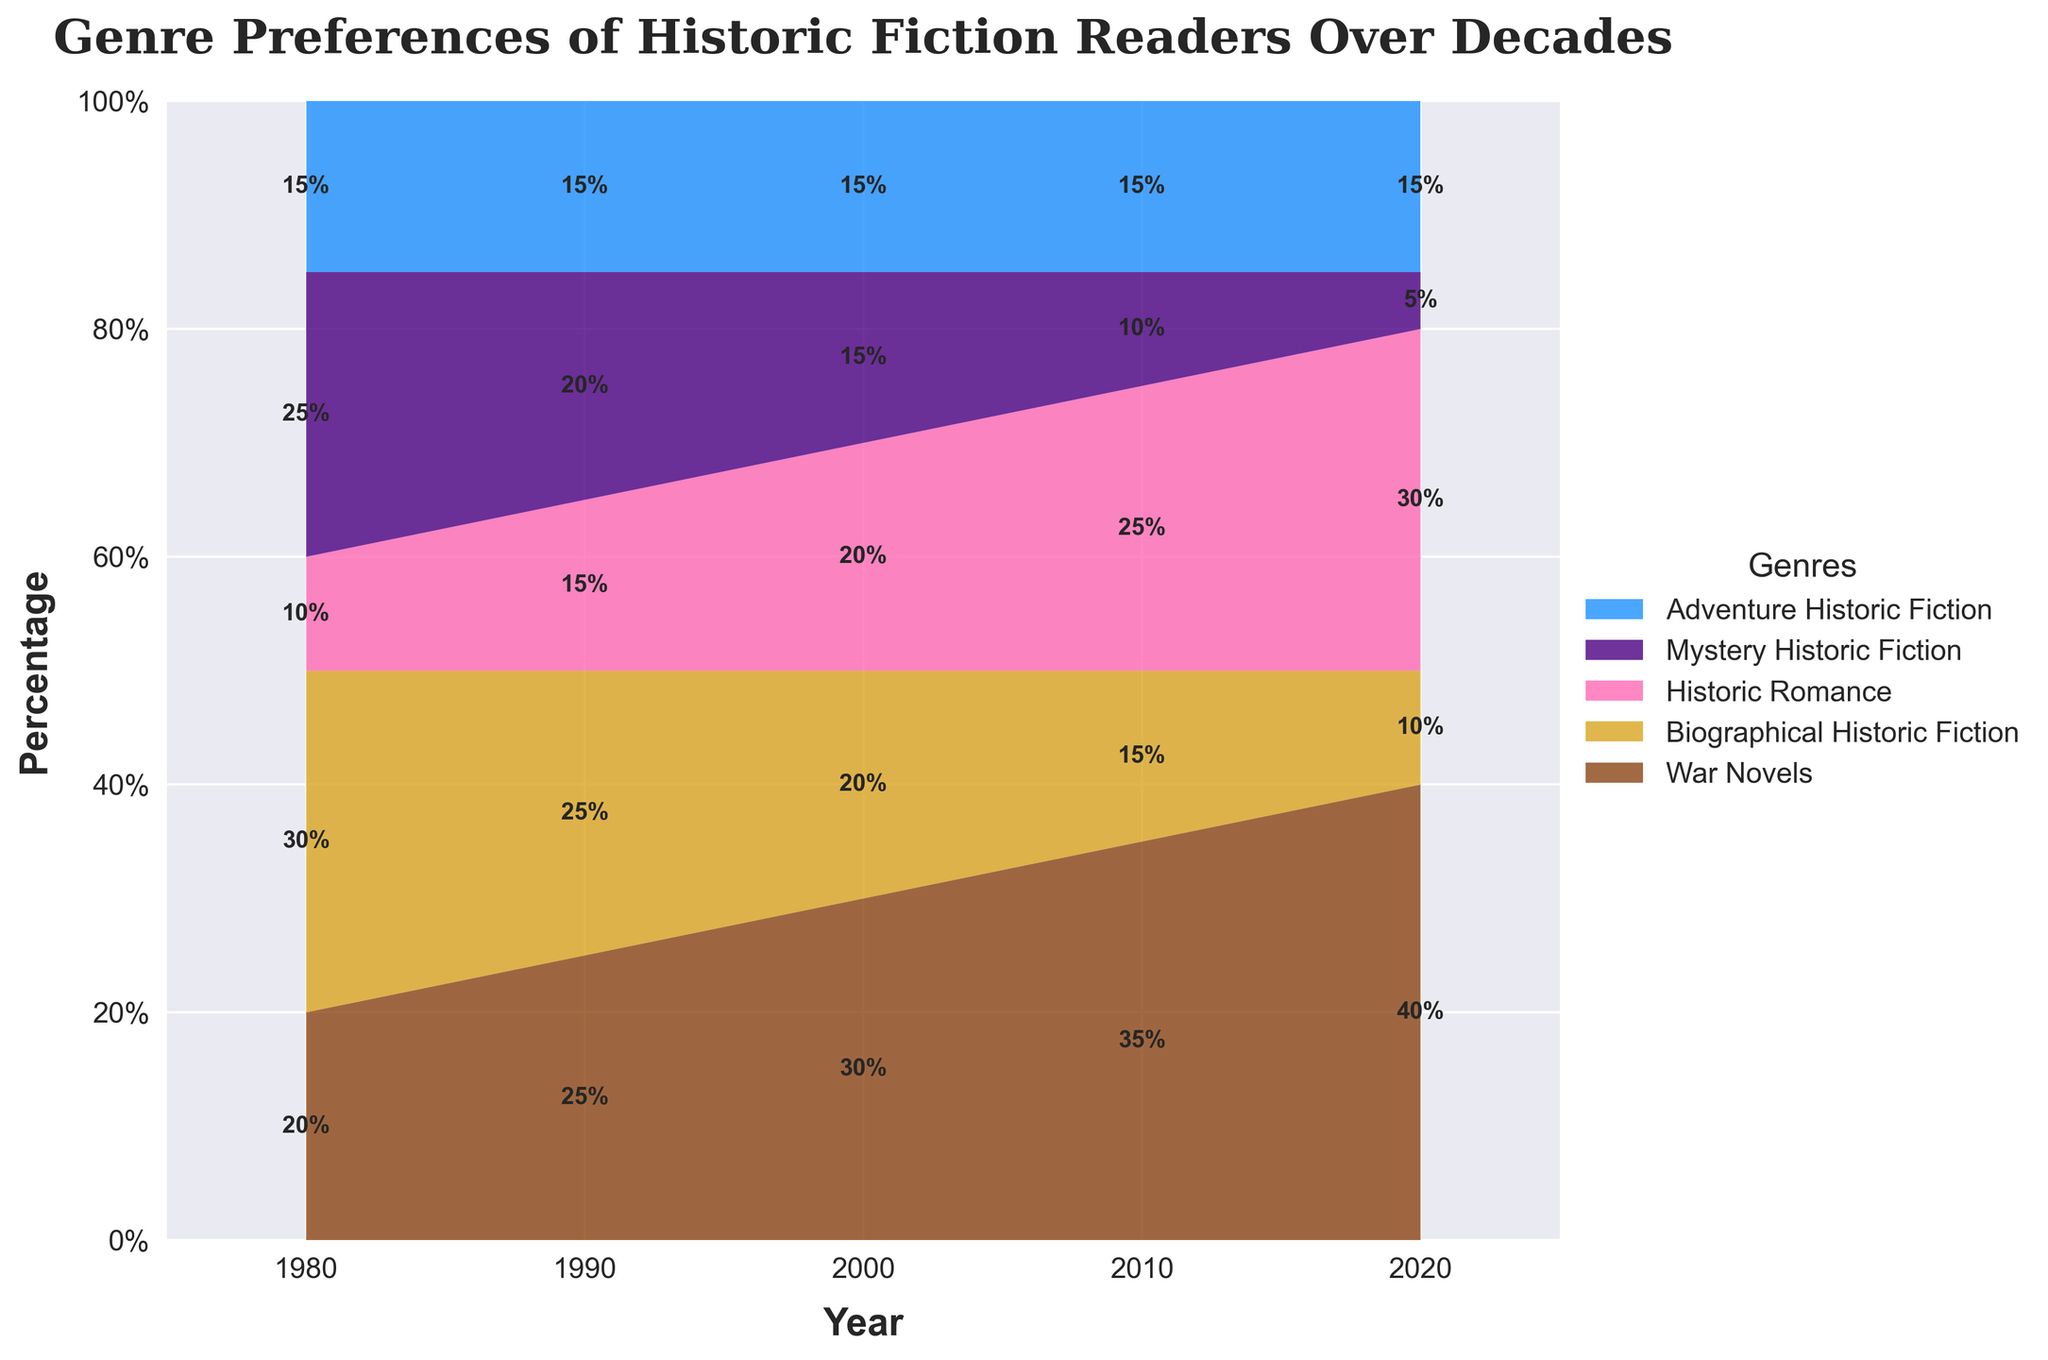What is the title of the figure? The title is usually located at the top of the figure and serves to provide an overview of the chart's content. In this case, the title reads "Genre Preferences of Historic Fiction Readers Over Decades".
Answer: Genre Preferences of Historic Fiction Readers Over Decades How many genres are shown in the figure? The figure includes several distinctly colored areas, each representing a different genre. By counting these areas, we find there are five genres represented: War Novels, Biographical Historic Fiction, Historic Romance, Mystery Historic Fiction, and Adventure Historic Fiction.
Answer: Five Which genre had the highest preference in 1980? To identify the genre with the highest preference in 1980, we look for the genre with the largest area at that year on the x-axis. War Novels and Adventure Historic Fiction have higher proportions compared to others, but the War Novels has the highest preference.
Answer: War Novels How did the preference for Historic Romance change from 1980 to 2020? We observe the vertical breadth of the area corresponding to Historic Romance at 1980 and 2020. In 1980, Historic Romance had around 10%, whereas in 2020, it increased to around 30%.
Answer: Increased Which genre's preference decreased the most from 1980 to 2020? To find the genre with the most significant decrease, compare the vertical heights of each area from 1980 to 2020. Biographical Historic Fiction decreased from 30% in 1980 to 10% in 2020.
Answer: Biographical Historic Fiction What is the combined percentage of Mystery Historic Fiction and Adventure Historic Fiction in 2010? To find the combined percentage, add the individual percentages for both genres in 2010. Mystery Historic Fiction is 10% and Adventure Historic Fiction is 15%, summing up to 25%.
Answer: 25% In which decade does War Novels start showing a clear increasing trend? We examine the area for War Novels across the decades. The increase becomes significant from 1990 onwards when it starts growing consistently each decade.
Answer: 1990s Compare the preferences of Biographical Historic Fiction and Historic Romance in 2000. Which was higher? To determine which genre was preferred more in 2000, compare the heights of the areas. Biographical Historic Fiction was 20% and Historic Romance was also 20%.
Answer: Equal During which decade did preference for Mystery Historic Fiction decline sharply? A sharp decline is marked by a noticeable reduction in the area's height from one decade to the next. The steepest decline for Mystery Historic Fiction happened between 2010 and 2020.
Answer: 2010 to 2020 